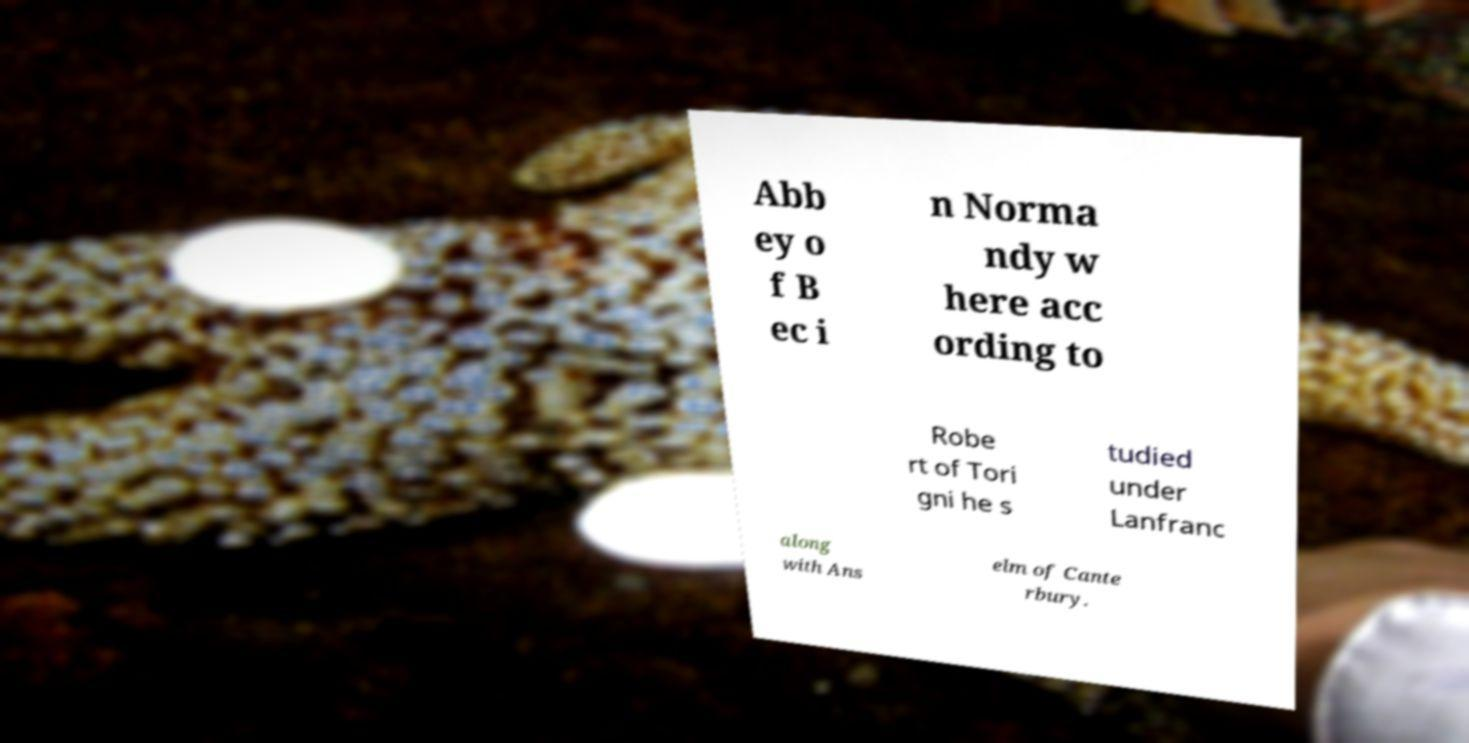Can you accurately transcribe the text from the provided image for me? Abb ey o f B ec i n Norma ndy w here acc ording to Robe rt of Tori gni he s tudied under Lanfranc along with Ans elm of Cante rbury. 